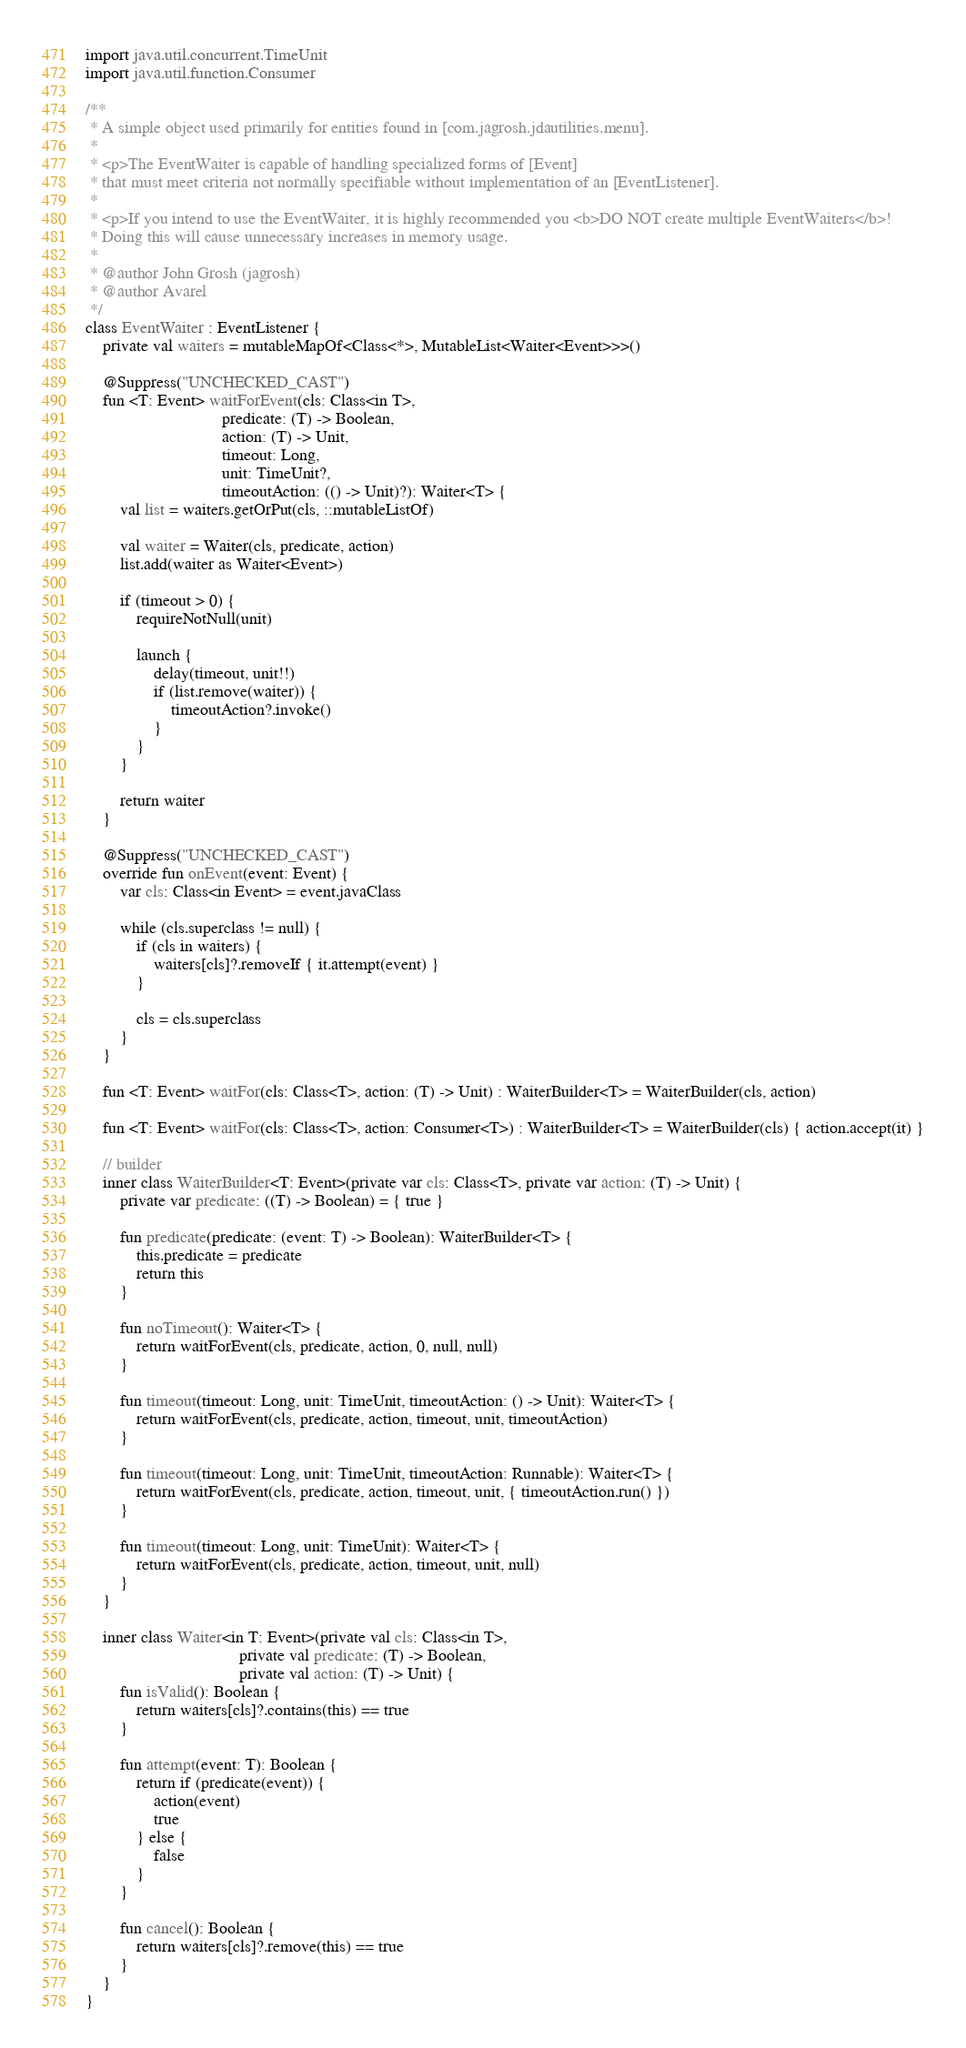<code> <loc_0><loc_0><loc_500><loc_500><_Kotlin_>import java.util.concurrent.TimeUnit
import java.util.function.Consumer

/**
 * A simple object used primarily for entities found in [com.jagrosh.jdautilities.menu].
 *
 * <p>The EventWaiter is capable of handling specialized forms of [Event]
 * that must meet criteria not normally specifiable without implementation of an [EventListener].
 *
 * <p>If you intend to use the EventWaiter, it is highly recommended you <b>DO NOT create multiple EventWaiters</b>!
 * Doing this will cause unnecessary increases in memory usage.
 *
 * @author John Grosh (jagrosh)
 * @author Avarel
 */
class EventWaiter : EventListener {
    private val waiters = mutableMapOf<Class<*>, MutableList<Waiter<Event>>>()

    @Suppress("UNCHECKED_CAST")
    fun <T: Event> waitForEvent(cls: Class<in T>,
                                predicate: (T) -> Boolean,
                                action: (T) -> Unit,
                                timeout: Long,
                                unit: TimeUnit?,
                                timeoutAction: (() -> Unit)?): Waiter<T> {
        val list = waiters.getOrPut(cls, ::mutableListOf)

        val waiter = Waiter(cls, predicate, action)
        list.add(waiter as Waiter<Event>)

        if (timeout > 0) {
            requireNotNull(unit)

            launch {
                delay(timeout, unit!!)
                if (list.remove(waiter)) {
                    timeoutAction?.invoke()
                }
            }
        }

        return waiter
    }

    @Suppress("UNCHECKED_CAST")
    override fun onEvent(event: Event) {
        var cls: Class<in Event> = event.javaClass

        while (cls.superclass != null) {
            if (cls in waiters) {
                waiters[cls]?.removeIf { it.attempt(event) }
            }

            cls = cls.superclass
        }
    }

    fun <T: Event> waitFor(cls: Class<T>, action: (T) -> Unit) : WaiterBuilder<T> = WaiterBuilder(cls, action)

    fun <T: Event> waitFor(cls: Class<T>, action: Consumer<T>) : WaiterBuilder<T> = WaiterBuilder(cls) { action.accept(it) }

    // builder
    inner class WaiterBuilder<T: Event>(private var cls: Class<T>, private var action: (T) -> Unit) {
        private var predicate: ((T) -> Boolean) = { true }

        fun predicate(predicate: (event: T) -> Boolean): WaiterBuilder<T> {
            this.predicate = predicate
            return this
        }

        fun noTimeout(): Waiter<T> {
            return waitForEvent(cls, predicate, action, 0, null, null)
        }

        fun timeout(timeout: Long, unit: TimeUnit, timeoutAction: () -> Unit): Waiter<T> {
            return waitForEvent(cls, predicate, action, timeout, unit, timeoutAction)
        }

        fun timeout(timeout: Long, unit: TimeUnit, timeoutAction: Runnable): Waiter<T> {
            return waitForEvent(cls, predicate, action, timeout, unit, { timeoutAction.run() })
        }

        fun timeout(timeout: Long, unit: TimeUnit): Waiter<T> {
            return waitForEvent(cls, predicate, action, timeout, unit, null)
        }
    }

    inner class Waiter<in T: Event>(private val cls: Class<in T>,
                                    private val predicate: (T) -> Boolean,
                                    private val action: (T) -> Unit) {
        fun isValid(): Boolean {
            return waiters[cls]?.contains(this) == true
        }

        fun attempt(event: T): Boolean {
            return if (predicate(event)) {
                action(event)
                true
            } else {
                false
            }
        }

        fun cancel(): Boolean {
            return waiters[cls]?.remove(this) == true
        }
    }
}</code> 